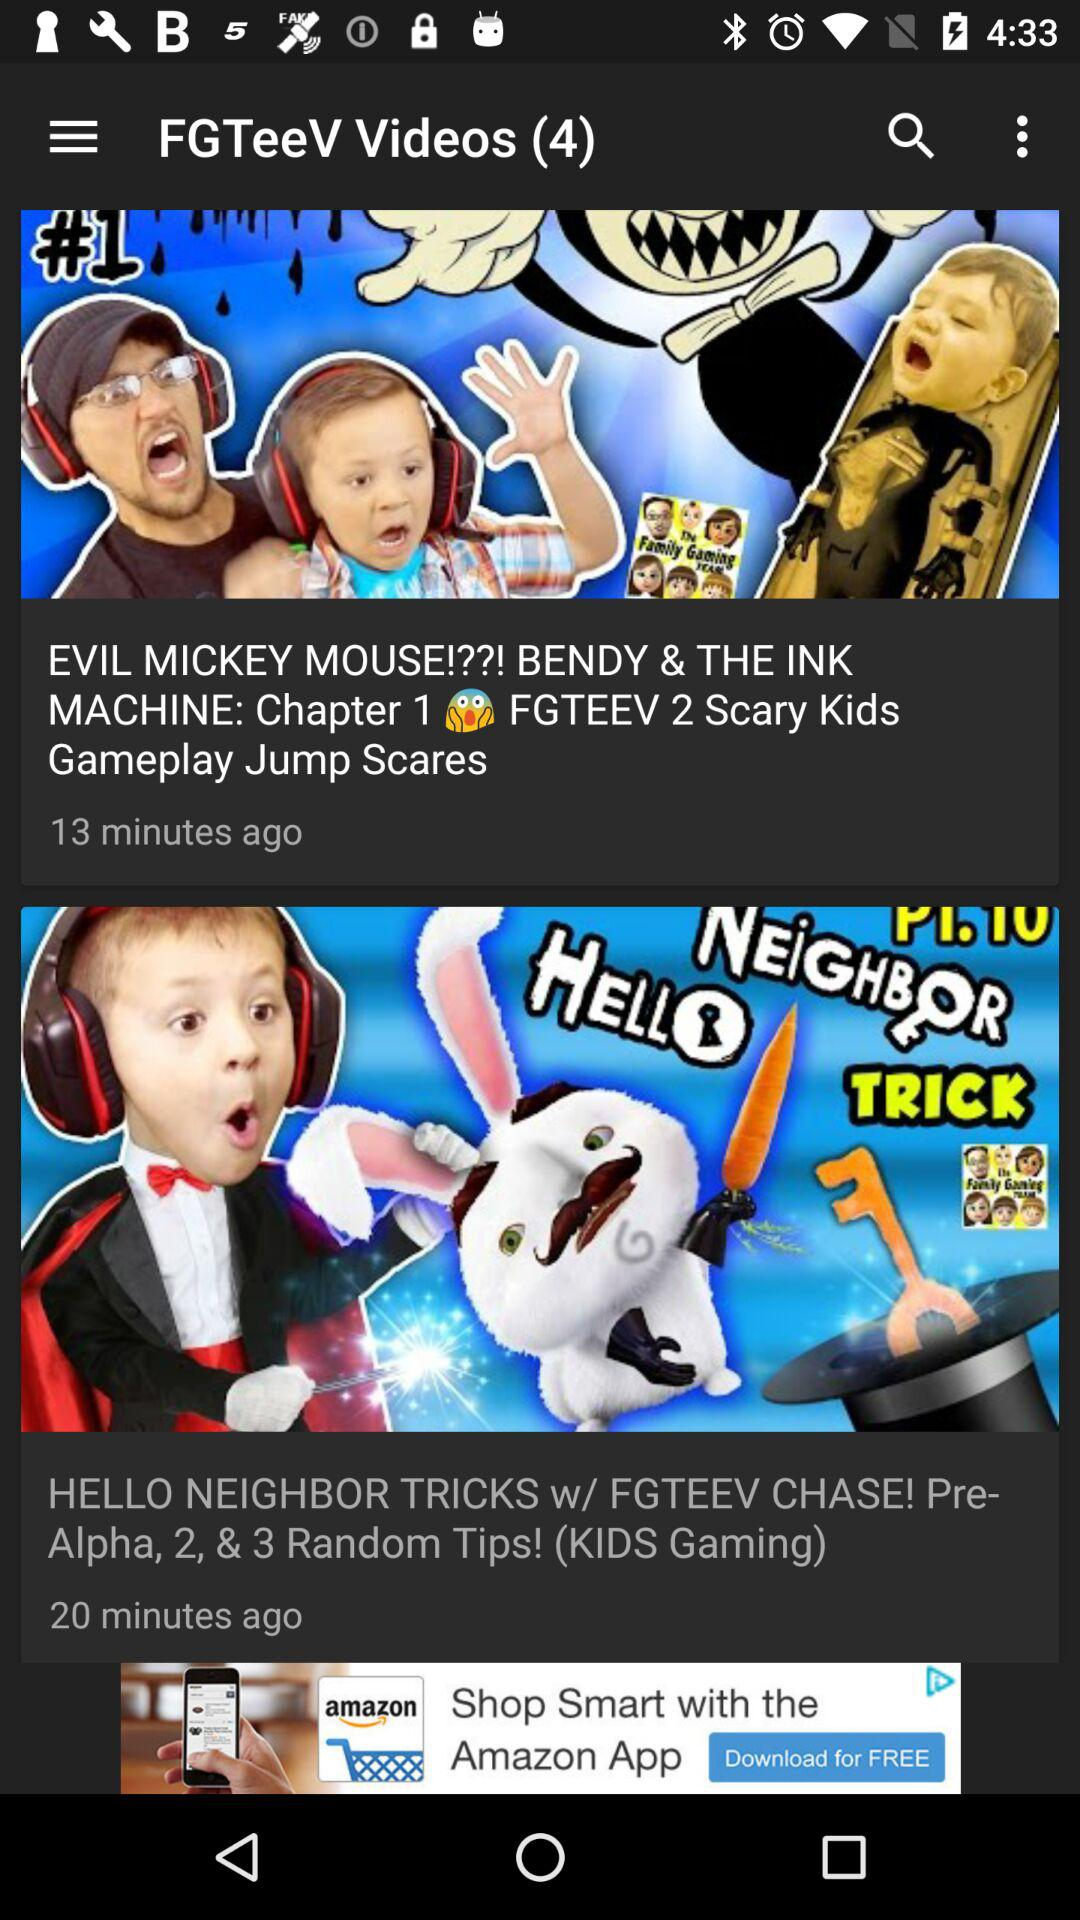When was the "HELLO NEIGHBOR TRICKS w/ FGTEEV CHASE! Pre Alpha, 2, & 3 Random Tips! (KIDS Gaming)" video posted? The video was posted 20 minutes ago. 